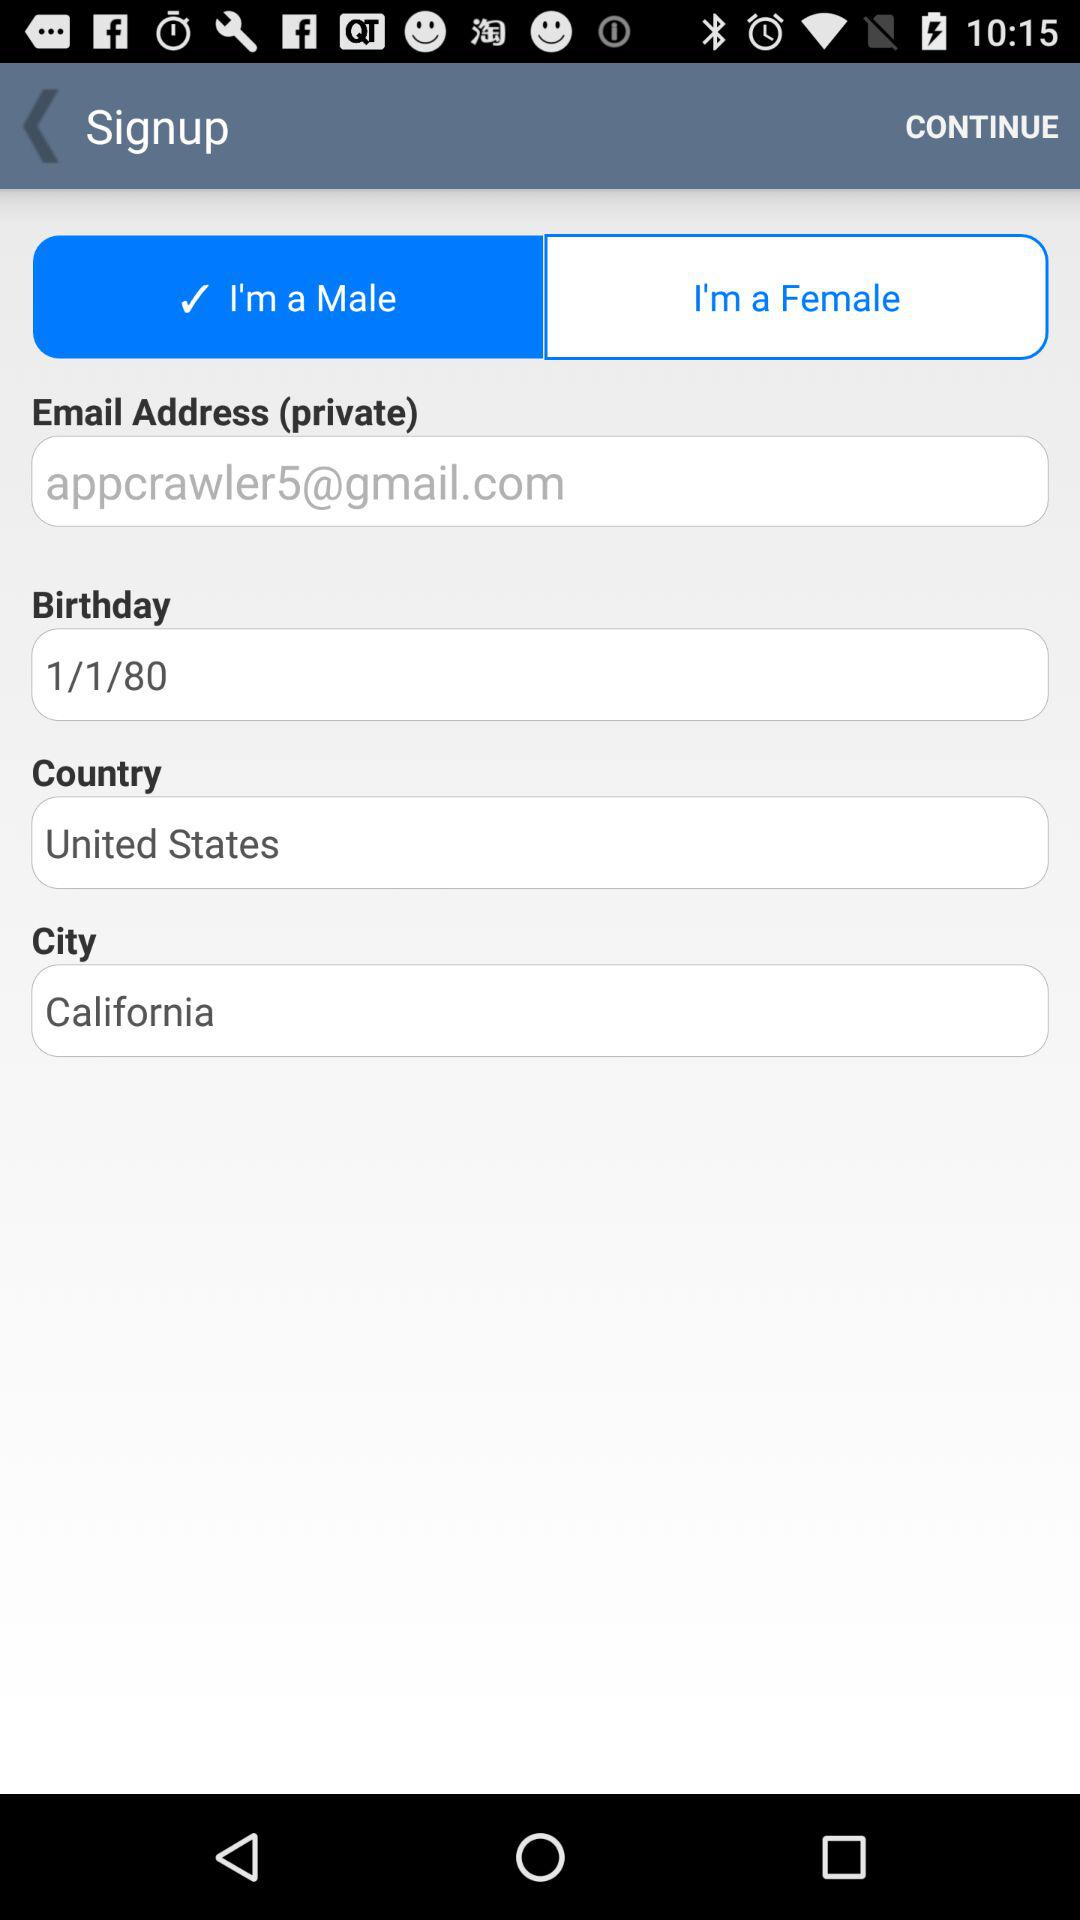What is the email address of the user? The email address is appcrawler5@gmail.com. 